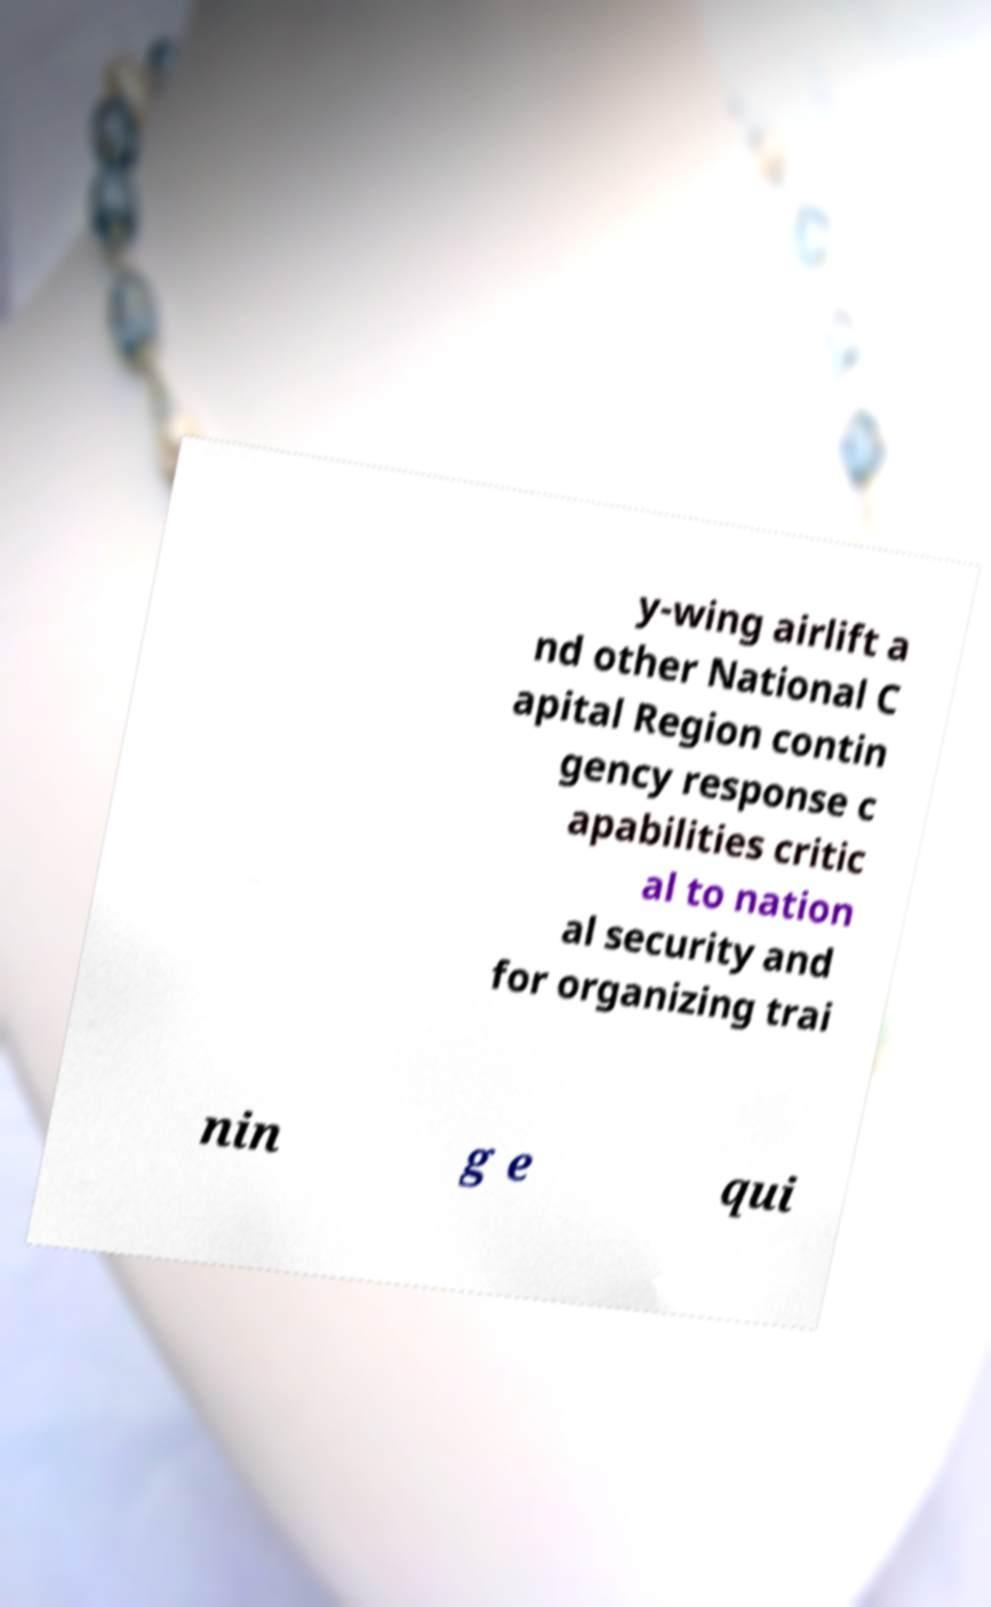For documentation purposes, I need the text within this image transcribed. Could you provide that? y-wing airlift a nd other National C apital Region contin gency response c apabilities critic al to nation al security and for organizing trai nin g e qui 